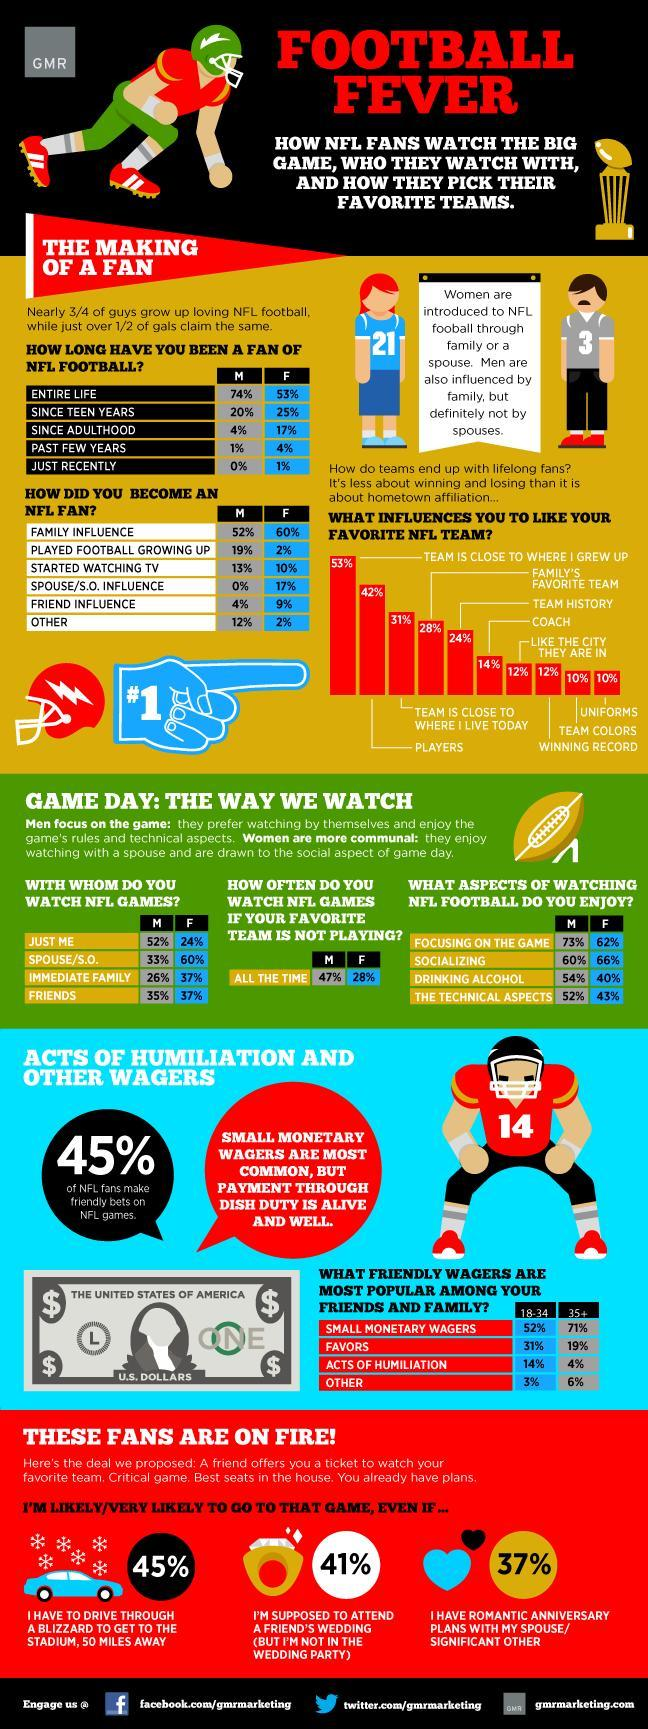What is the % of the men(M) who has been a fan of NFL football since teen years?
Answer the question with a short phrase. 20 What is the number written on the vector image to represent women/female? 21 Which factor does equally influences people to like their favorite NFL team as team colors of the team? uniforms Which factor does equally influences people to like their favorite NFL team as winning record of the team? like the city they are in Who is more likely to watch NLF games even if their favorite team is not playing, M or F? M What is the % of the women(F) who has been a fan of NFL football since adulthood? 17% What influences women(F) most to become an NFL fan? family How many factors are considered here to make the bar chart on what influences people to choose their favorite NFL team? 10 Which factor does have no influence on man to become an NFL fan? spouse/s. o. influence Who is more influenced by their family to become an NFL fan, M or F? F Who is more influenced by their friends to become an NFL fan, M or F? F 